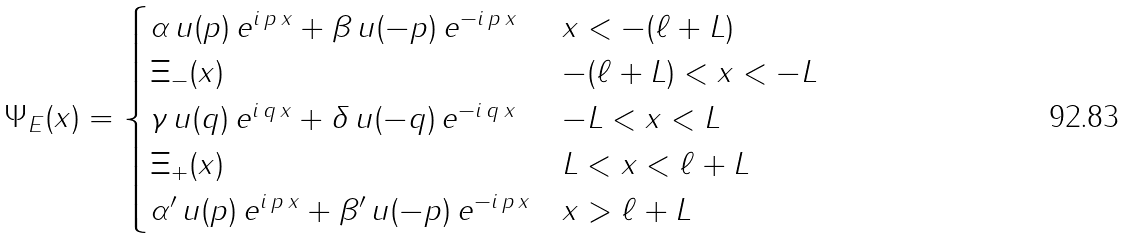<formula> <loc_0><loc_0><loc_500><loc_500>\Psi _ { E } ( x ) = \begin{cases} \alpha \, u ( p ) \, e ^ { i \, p \, x } + \beta \, u ( - p ) \, e ^ { - i \, p \, x } & x < - ( \ell + L ) \\ \Xi _ { - } ( x ) & - ( \ell + L ) < x < - L \\ \gamma \, u ( q ) \, e ^ { i \, q \, x } + \delta \, u ( - q ) \, e ^ { - i \, q \, x } & - L < x < L \\ \Xi _ { + } ( x ) & L < x < \ell + L \\ \alpha ^ { \prime } \, u ( p ) \, e ^ { i \, p \, x } + \beta ^ { \prime } \, u ( - p ) \, e ^ { - i \, p \, x } & x > \ell + L \end{cases}</formula> 